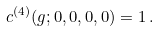<formula> <loc_0><loc_0><loc_500><loc_500>c ^ { ( 4 ) } ( g ; 0 , 0 , 0 , 0 ) = 1 \, .</formula> 